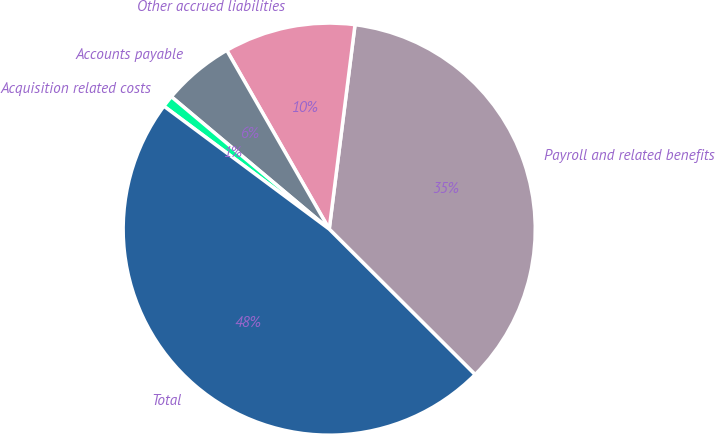Convert chart. <chart><loc_0><loc_0><loc_500><loc_500><pie_chart><fcel>Payroll and related benefits<fcel>Other accrued liabilities<fcel>Accounts payable<fcel>Acquisition related costs<fcel>Total<nl><fcel>35.48%<fcel>10.28%<fcel>5.61%<fcel>0.93%<fcel>47.7%<nl></chart> 